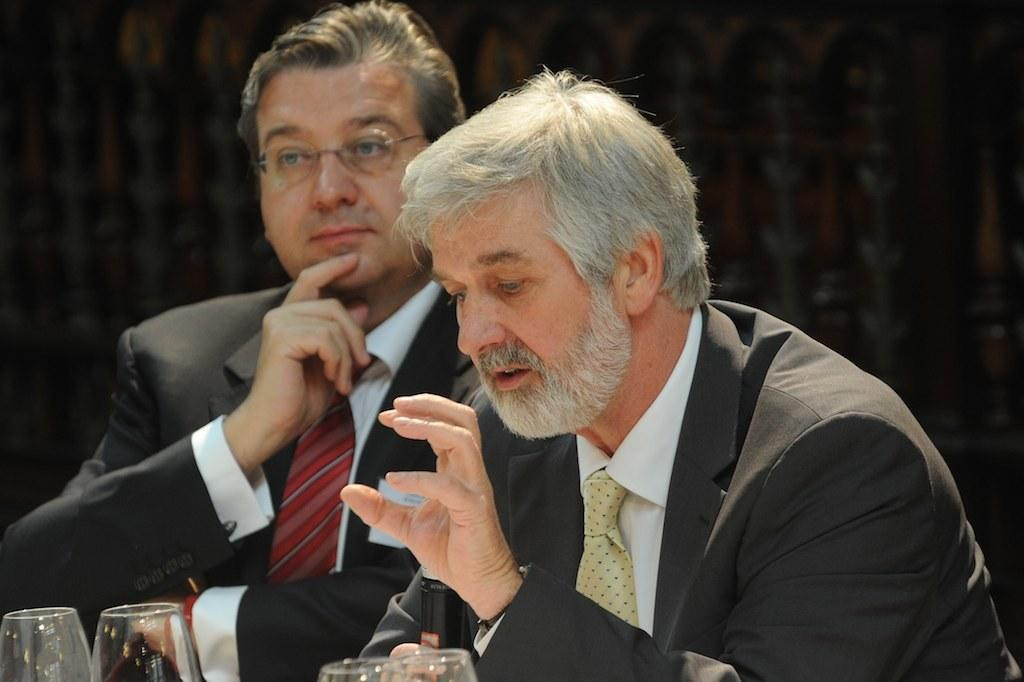How many people are in the image? There are two people in the image. What are the people wearing? Both people are wearing suits. What are the people doing in the image? The people are sitting. What objects can be seen in the image besides the people? There are glasses in the image. How many eyes can be seen on the carpenter in the image? There is no carpenter present in the image, and therefore no eyes can be seen on a carpenter. 